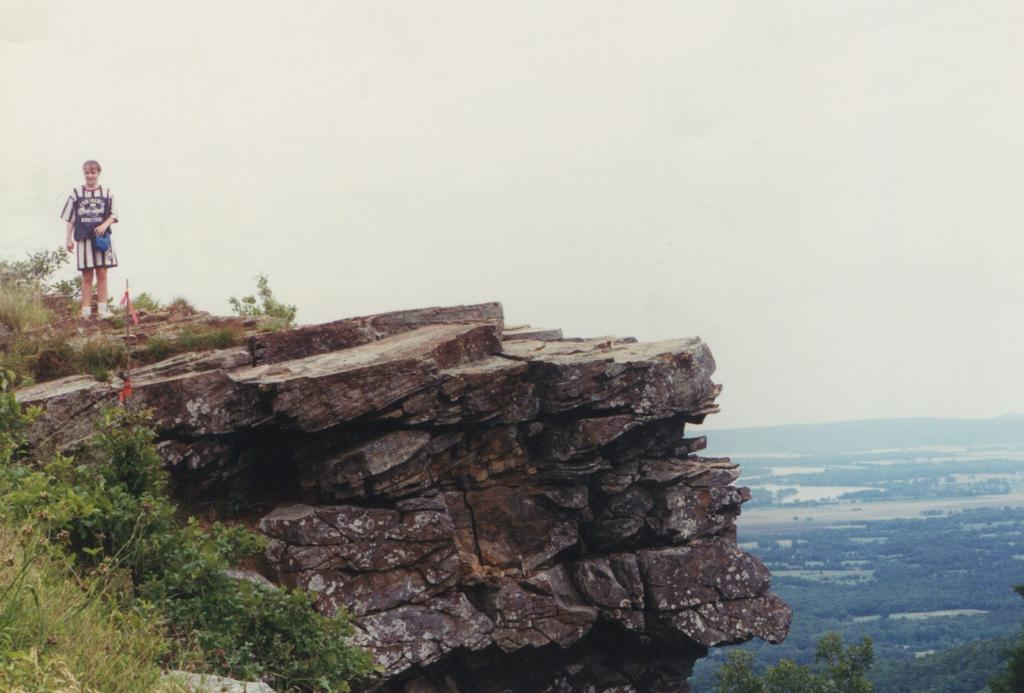What geographical feature is present in the image? There is a hill in the image. Is there anyone on the hill? Yes, there is a person on the hill. What type of vegetation can be seen in the image? There are plants, trees, and plants with trees in the image. Can you describe the water visible in the image? The image shows water, but it doesn't provide any specific details about the water. How does the person on the hill show respect to the trees in the image? There is no indication in the image of the person showing respect to the trees. Can you tell me how many times the person kicks the water in the image? There is no indication in the image of the person kicking the water. 